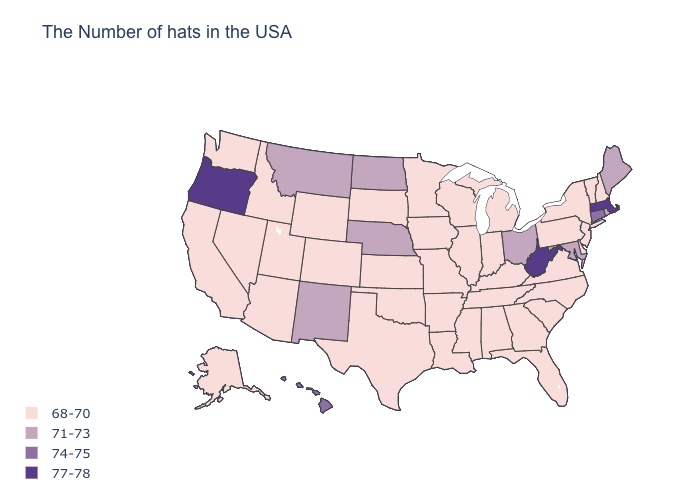Does Pennsylvania have the highest value in the USA?
Answer briefly. No. How many symbols are there in the legend?
Be succinct. 4. Name the states that have a value in the range 77-78?
Short answer required. Massachusetts, West Virginia, Oregon. Does New Hampshire have a lower value than North Dakota?
Write a very short answer. Yes. Is the legend a continuous bar?
Be succinct. No. Does the first symbol in the legend represent the smallest category?
Concise answer only. Yes. What is the lowest value in the Northeast?
Be succinct. 68-70. Does North Carolina have the same value as Idaho?
Quick response, please. Yes. Does Minnesota have the highest value in the MidWest?
Concise answer only. No. Name the states that have a value in the range 74-75?
Quick response, please. Connecticut, Hawaii. Which states have the lowest value in the USA?
Quick response, please. New Hampshire, Vermont, New York, New Jersey, Delaware, Pennsylvania, Virginia, North Carolina, South Carolina, Florida, Georgia, Michigan, Kentucky, Indiana, Alabama, Tennessee, Wisconsin, Illinois, Mississippi, Louisiana, Missouri, Arkansas, Minnesota, Iowa, Kansas, Oklahoma, Texas, South Dakota, Wyoming, Colorado, Utah, Arizona, Idaho, Nevada, California, Washington, Alaska. Name the states that have a value in the range 71-73?
Be succinct. Maine, Rhode Island, Maryland, Ohio, Nebraska, North Dakota, New Mexico, Montana. What is the highest value in the USA?
Write a very short answer. 77-78. Does Oregon have the lowest value in the West?
Give a very brief answer. No. 